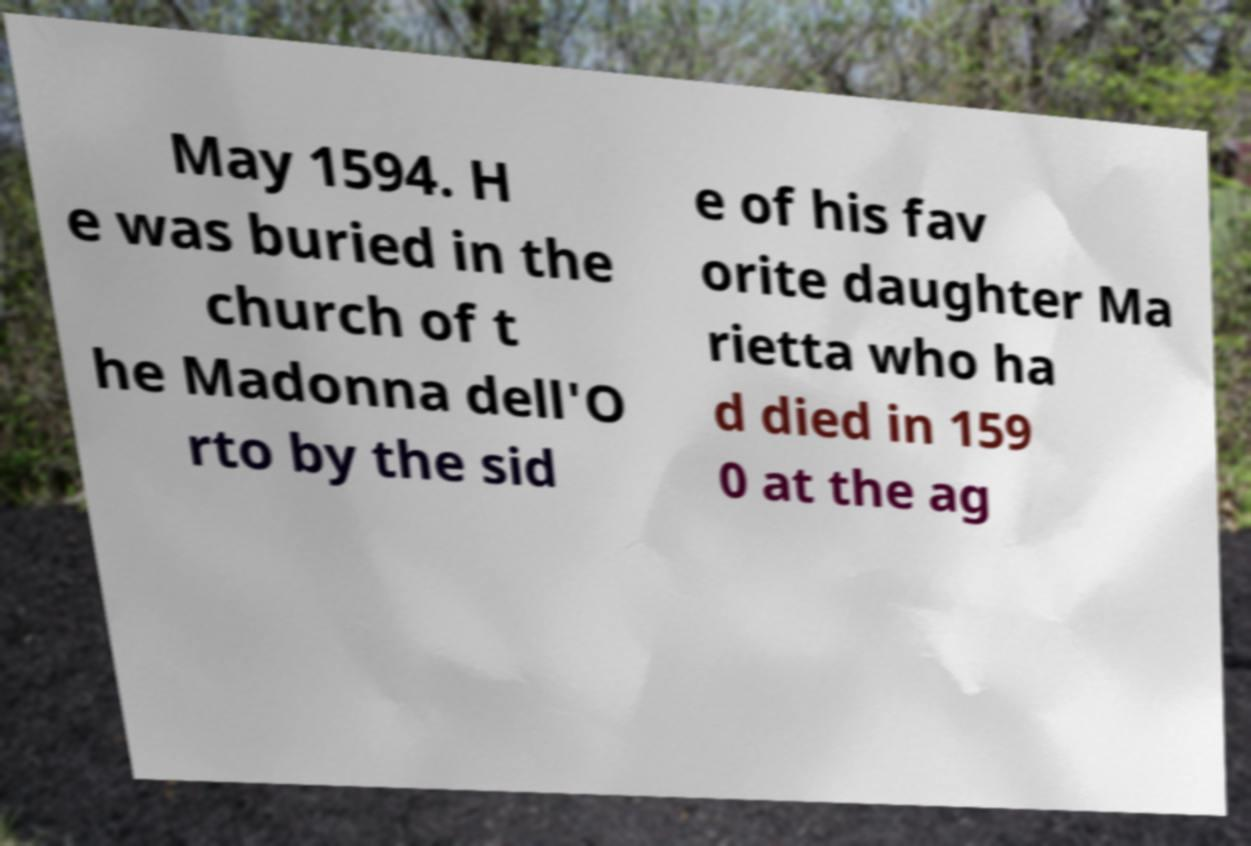What messages or text are displayed in this image? I need them in a readable, typed format. May 1594. H e was buried in the church of t he Madonna dell'O rto by the sid e of his fav orite daughter Ma rietta who ha d died in 159 0 at the ag 